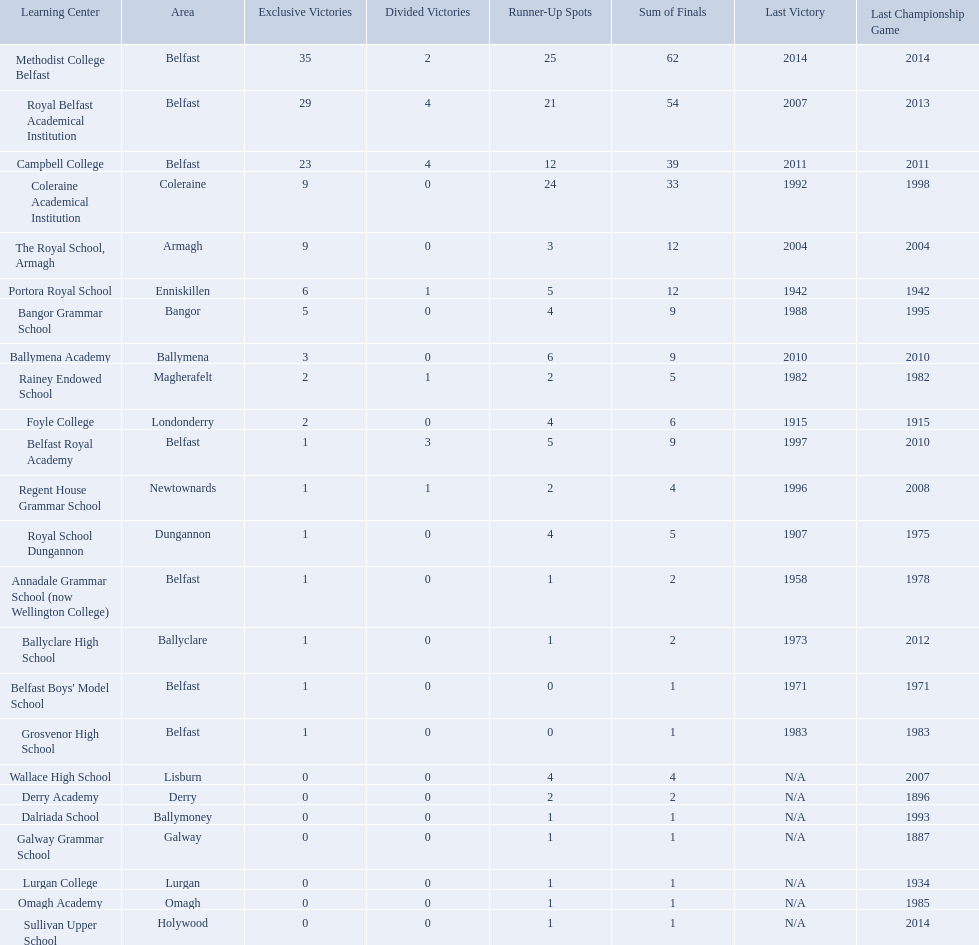What were all of the school names? Methodist College Belfast, Royal Belfast Academical Institution, Campbell College, Coleraine Academical Institution, The Royal School, Armagh, Portora Royal School, Bangor Grammar School, Ballymena Academy, Rainey Endowed School, Foyle College, Belfast Royal Academy, Regent House Grammar School, Royal School Dungannon, Annadale Grammar School (now Wellington College), Ballyclare High School, Belfast Boys' Model School, Grosvenor High School, Wallace High School, Derry Academy, Dalriada School, Galway Grammar School, Lurgan College, Omagh Academy, Sullivan Upper School. How many outright titles did they achieve? 35, 29, 23, 9, 9, 6, 5, 3, 2, 2, 1, 1, 1, 1, 1, 1, 1, 0, 0, 0, 0, 0, 0, 0. And how many did coleraine academical institution receive? 9. Which other school had the same number of outright titles? The Royal School, Armagh. How many schools are there? Methodist College Belfast, Royal Belfast Academical Institution, Campbell College, Coleraine Academical Institution, The Royal School, Armagh, Portora Royal School, Bangor Grammar School, Ballymena Academy, Rainey Endowed School, Foyle College, Belfast Royal Academy, Regent House Grammar School, Royal School Dungannon, Annadale Grammar School (now Wellington College), Ballyclare High School, Belfast Boys' Model School, Grosvenor High School, Wallace High School, Derry Academy, Dalriada School, Galway Grammar School, Lurgan College, Omagh Academy, Sullivan Upper School. How many outright titles does the coleraine academical institution have? 9. What other school has the same number of outright titles? The Royal School, Armagh. Which schools are listed? Methodist College Belfast, Royal Belfast Academical Institution, Campbell College, Coleraine Academical Institution, The Royal School, Armagh, Portora Royal School, Bangor Grammar School, Ballymena Academy, Rainey Endowed School, Foyle College, Belfast Royal Academy, Regent House Grammar School, Royal School Dungannon, Annadale Grammar School (now Wellington College), Ballyclare High School, Belfast Boys' Model School, Grosvenor High School, Wallace High School, Derry Academy, Dalriada School, Galway Grammar School, Lurgan College, Omagh Academy, Sullivan Upper School. Could you help me parse every detail presented in this table? {'header': ['Learning Center', 'Area', 'Exclusive Victories', 'Divided Victories', 'Runner-Up Spots', 'Sum of Finals', 'Last Victory', 'Last Championship Game'], 'rows': [['Methodist College Belfast', 'Belfast', '35', '2', '25', '62', '2014', '2014'], ['Royal Belfast Academical Institution', 'Belfast', '29', '4', '21', '54', '2007', '2013'], ['Campbell College', 'Belfast', '23', '4', '12', '39', '2011', '2011'], ['Coleraine Academical Institution', 'Coleraine', '9', '0', '24', '33', '1992', '1998'], ['The Royal School, Armagh', 'Armagh', '9', '0', '3', '12', '2004', '2004'], ['Portora Royal School', 'Enniskillen', '6', '1', '5', '12', '1942', '1942'], ['Bangor Grammar School', 'Bangor', '5', '0', '4', '9', '1988', '1995'], ['Ballymena Academy', 'Ballymena', '3', '0', '6', '9', '2010', '2010'], ['Rainey Endowed School', 'Magherafelt', '2', '1', '2', '5', '1982', '1982'], ['Foyle College', 'Londonderry', '2', '0', '4', '6', '1915', '1915'], ['Belfast Royal Academy', 'Belfast', '1', '3', '5', '9', '1997', '2010'], ['Regent House Grammar School', 'Newtownards', '1', '1', '2', '4', '1996', '2008'], ['Royal School Dungannon', 'Dungannon', '1', '0', '4', '5', '1907', '1975'], ['Annadale Grammar School (now Wellington College)', 'Belfast', '1', '0', '1', '2', '1958', '1978'], ['Ballyclare High School', 'Ballyclare', '1', '0', '1', '2', '1973', '2012'], ["Belfast Boys' Model School", 'Belfast', '1', '0', '0', '1', '1971', '1971'], ['Grosvenor High School', 'Belfast', '1', '0', '0', '1', '1983', '1983'], ['Wallace High School', 'Lisburn', '0', '0', '4', '4', 'N/A', '2007'], ['Derry Academy', 'Derry', '0', '0', '2', '2', 'N/A', '1896'], ['Dalriada School', 'Ballymoney', '0', '0', '1', '1', 'N/A', '1993'], ['Galway Grammar School', 'Galway', '0', '0', '1', '1', 'N/A', '1887'], ['Lurgan College', 'Lurgan', '0', '0', '1', '1', 'N/A', '1934'], ['Omagh Academy', 'Omagh', '0', '0', '1', '1', 'N/A', '1985'], ['Sullivan Upper School', 'Holywood', '0', '0', '1', '1', 'N/A', '2014']]} When did campbell college win the title last? 2011. When did regent house grammar school win the title last? 1996. Of those two who had the most recent title win? Campbell College. Which colleges participated in the ulster's schools' cup? Methodist College Belfast, Royal Belfast Academical Institution, Campbell College, Coleraine Academical Institution, The Royal School, Armagh, Portora Royal School, Bangor Grammar School, Ballymena Academy, Rainey Endowed School, Foyle College, Belfast Royal Academy, Regent House Grammar School, Royal School Dungannon, Annadale Grammar School (now Wellington College), Ballyclare High School, Belfast Boys' Model School, Grosvenor High School, Wallace High School, Derry Academy, Dalriada School, Galway Grammar School, Lurgan College, Omagh Academy, Sullivan Upper School. Of these, which are from belfast? Methodist College Belfast, Royal Belfast Academical Institution, Campbell College, Belfast Royal Academy, Annadale Grammar School (now Wellington College), Belfast Boys' Model School, Grosvenor High School. Of these, which have more than 20 outright titles? Methodist College Belfast, Royal Belfast Academical Institution, Campbell College. Which of these have the fewest runners-up? Campbell College. 